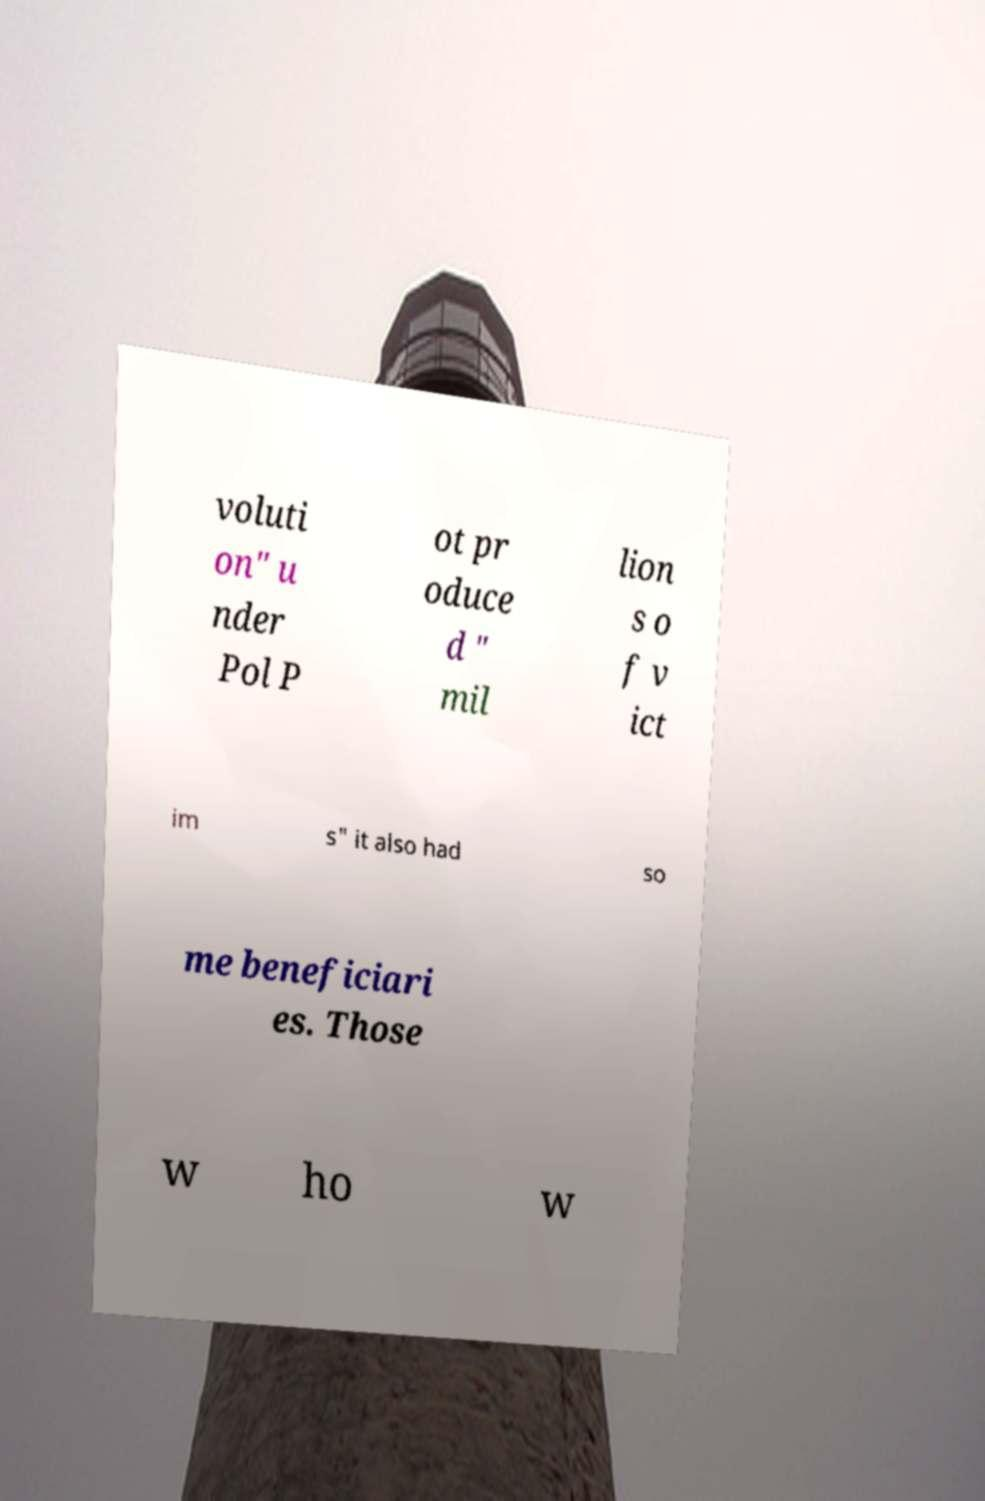Please identify and transcribe the text found in this image. voluti on" u nder Pol P ot pr oduce d " mil lion s o f v ict im s" it also had so me beneficiari es. Those w ho w 